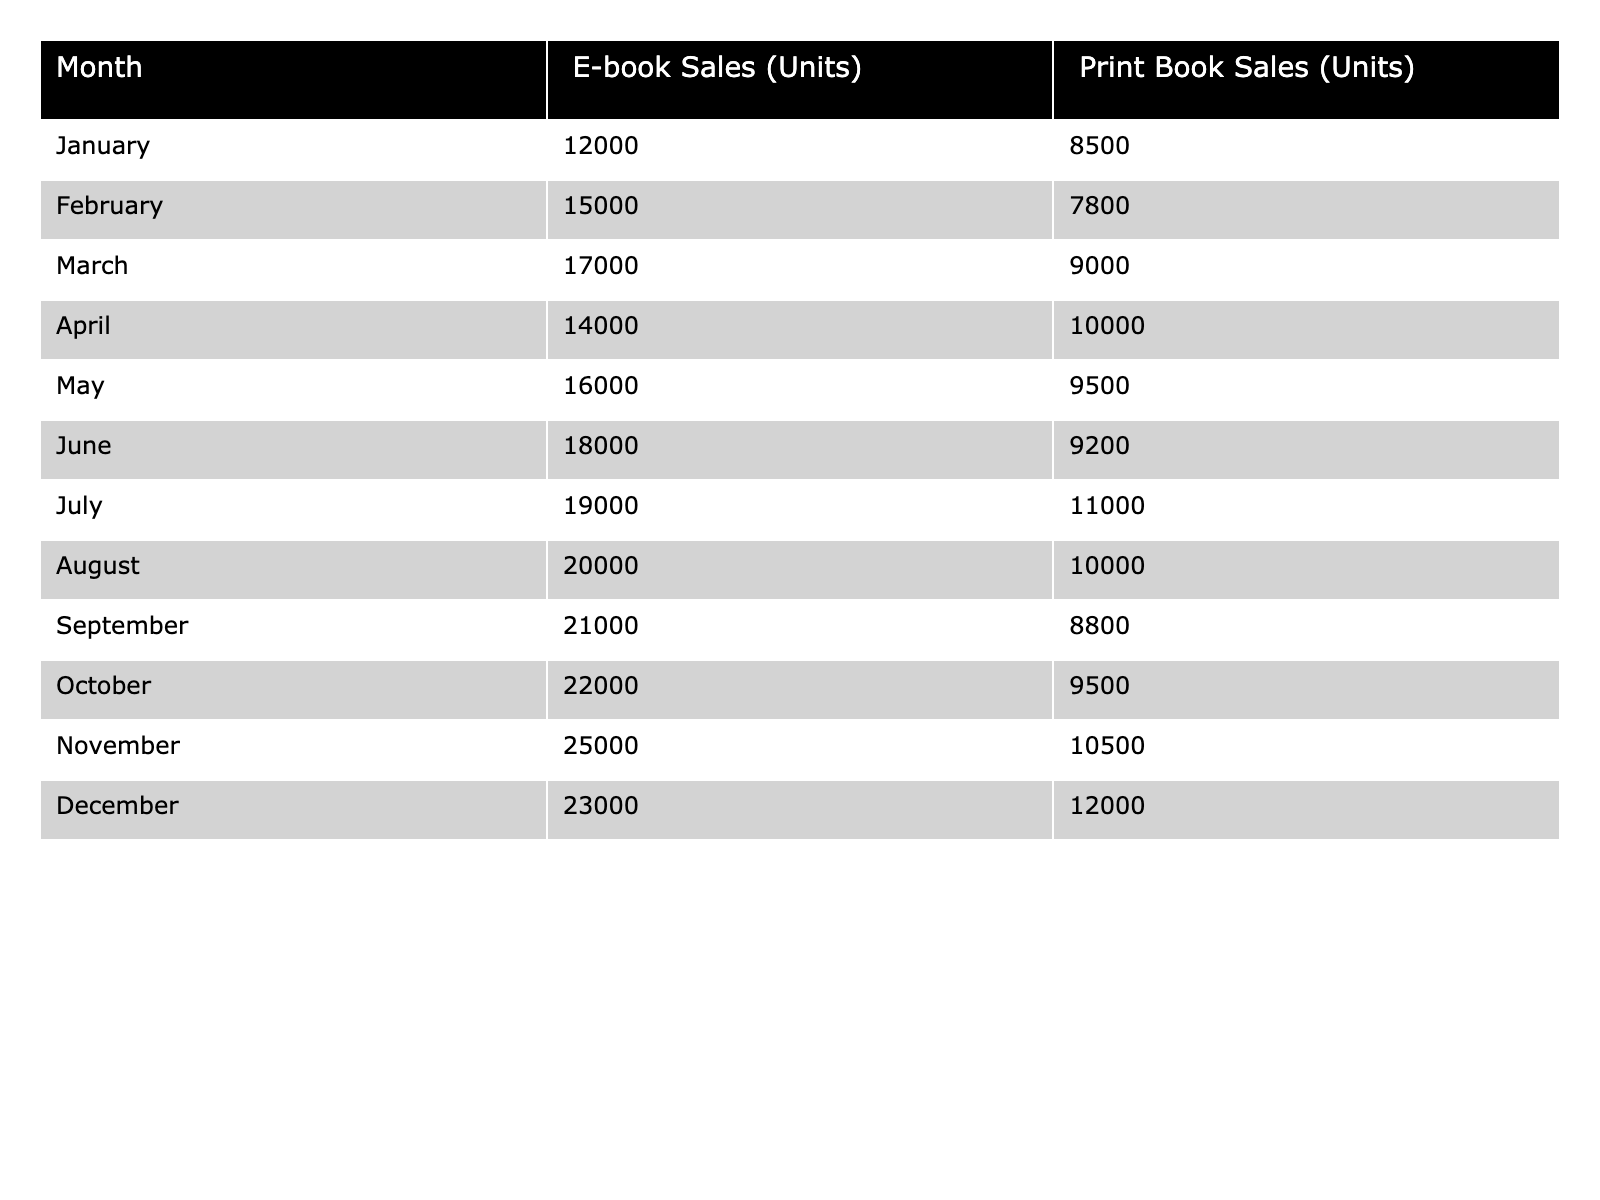What was the total number of e-book sales in November? The table shows that November had e-book sales of 25,000 units.
Answer: 25000 Which month had the highest print book sales? December recorded the highest print book sales with 12,000 units.
Answer: 12000 What is the difference in sales between e-books and print books in March? In March, e-book sales were 17,000 and print book sales were 9,000. The difference is 17,000 - 9,000 = 8,000.
Answer: 8000 What month had the lowest e-book sales? The lowest e-book sales occurred in January with 12,000 units.
Answer: January What is the average number of print book sales across all months? The total print book sales over the year are calculated by summing all monthly sales (8,500 + 7,800 + 9,000 + 10,000 + 9,500 + 9,200 + 11,000 + 10,000 + 8,800 + 9,500 + 10,500 + 12,000) = 9,900. Then, dividing by 12 months gives an average of 9,900 / 12 = 825.
Answer: 825 In which month did print book sales surpass 10,000 units? Print book sales exceeded 10,000 units in April, July, November, and December according to the table.
Answer: April, July, November, December What is the total number of e-book sales over the year? To find the total e-book sales, sum the monthly sales: 12,000 + 15,000 + 17,000 + 14,000 + 16,000 + 18,000 + 19,000 + 20,000 + 21,000 + 22,000 + 25,000 + 23,000 =  226,000.
Answer: 226000 Which month had a decrease in e-book sales compared to the previous month? Comparing the table data, October had e-book sales of 22,000, but December had lower sales of 23,000.
Answer: None Calculate the ratio of e-book sales to print book sales in July. In July, e-book sales were 19,000 and print book sales were 11,000. The ratio is 19,000 / 11,000 = 1.73 (approximately).
Answer: 1.73 Was there ever a month where print book sales were higher than e-book sales? Reviewing the data, there was no month where print book sales surpassed e-book sales.
Answer: No 